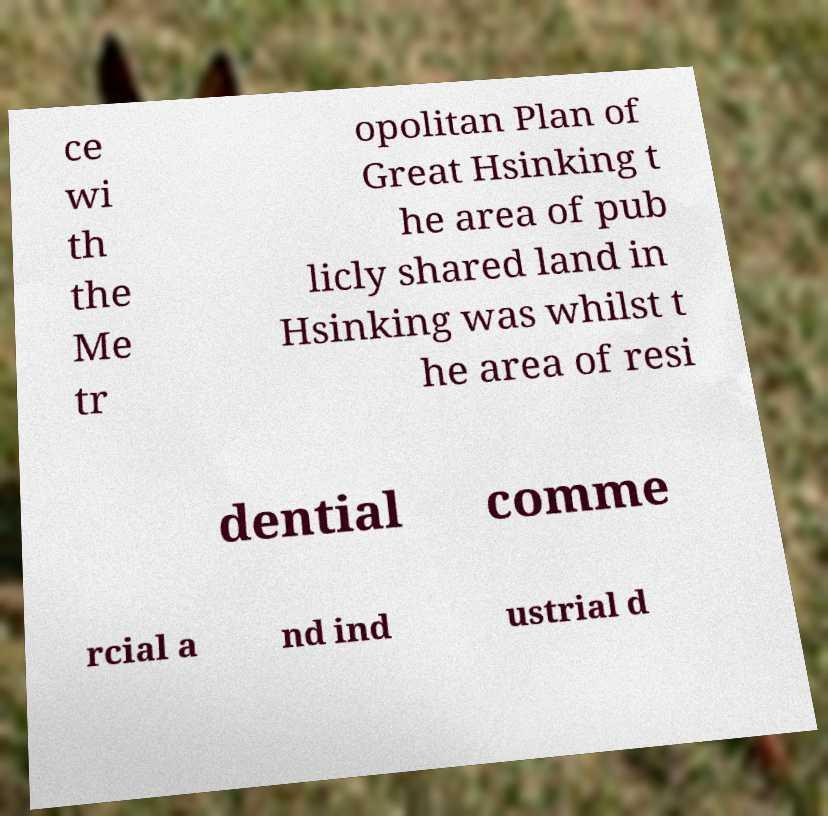What messages or text are displayed in this image? I need them in a readable, typed format. ce wi th the Me tr opolitan Plan of Great Hsinking t he area of pub licly shared land in Hsinking was whilst t he area of resi dential comme rcial a nd ind ustrial d 